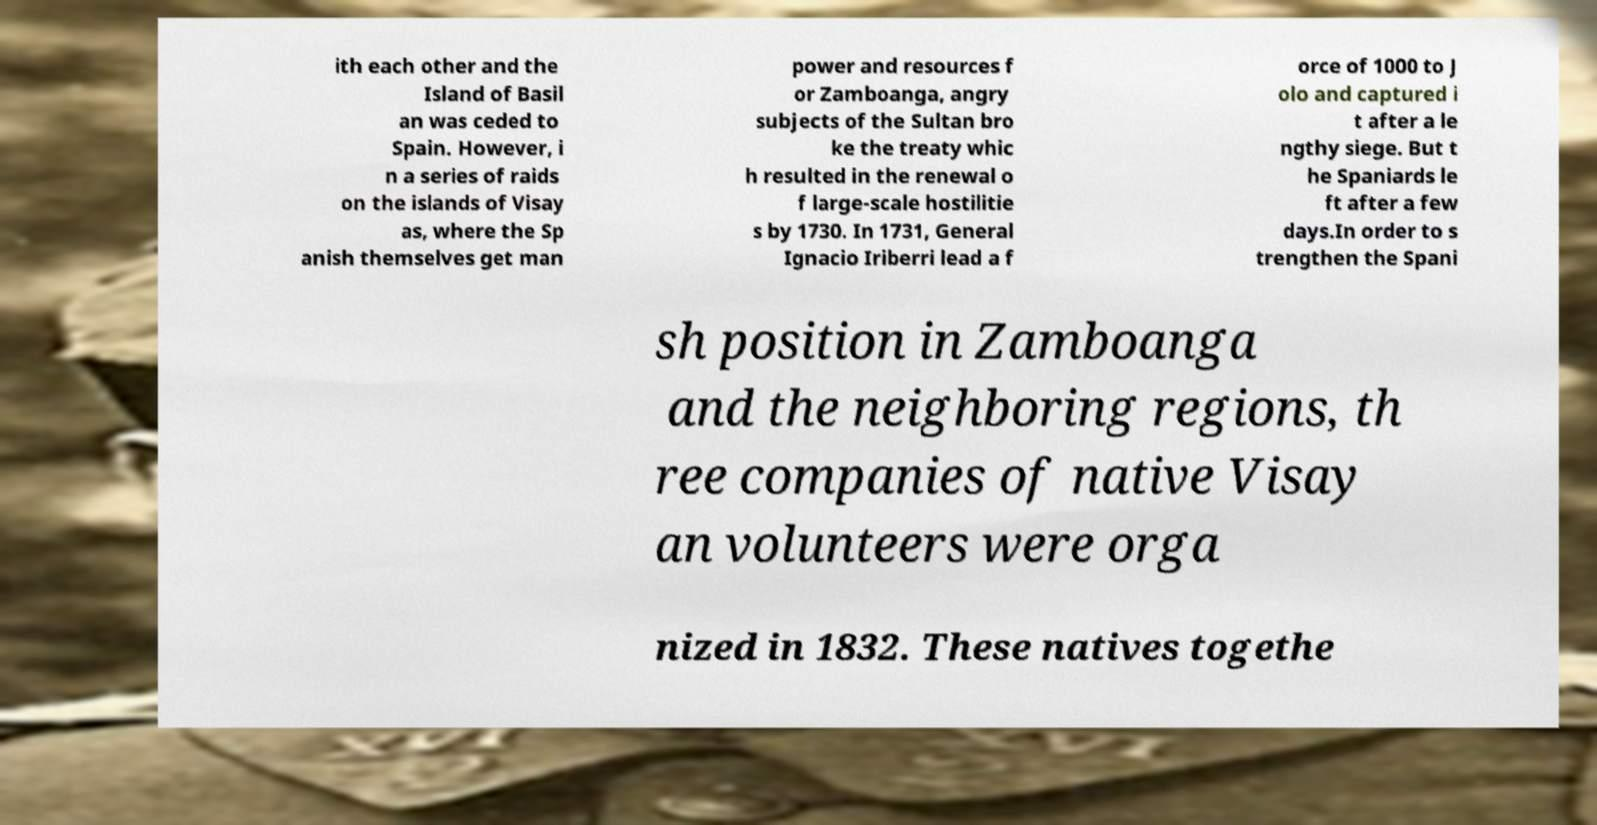There's text embedded in this image that I need extracted. Can you transcribe it verbatim? ith each other and the Island of Basil an was ceded to Spain. However, i n a series of raids on the islands of Visay as, where the Sp anish themselves get man power and resources f or Zamboanga, angry subjects of the Sultan bro ke the treaty whic h resulted in the renewal o f large-scale hostilitie s by 1730. In 1731, General Ignacio Iriberri lead a f orce of 1000 to J olo and captured i t after a le ngthy siege. But t he Spaniards le ft after a few days.In order to s trengthen the Spani sh position in Zamboanga and the neighboring regions, th ree companies of native Visay an volunteers were orga nized in 1832. These natives togethe 